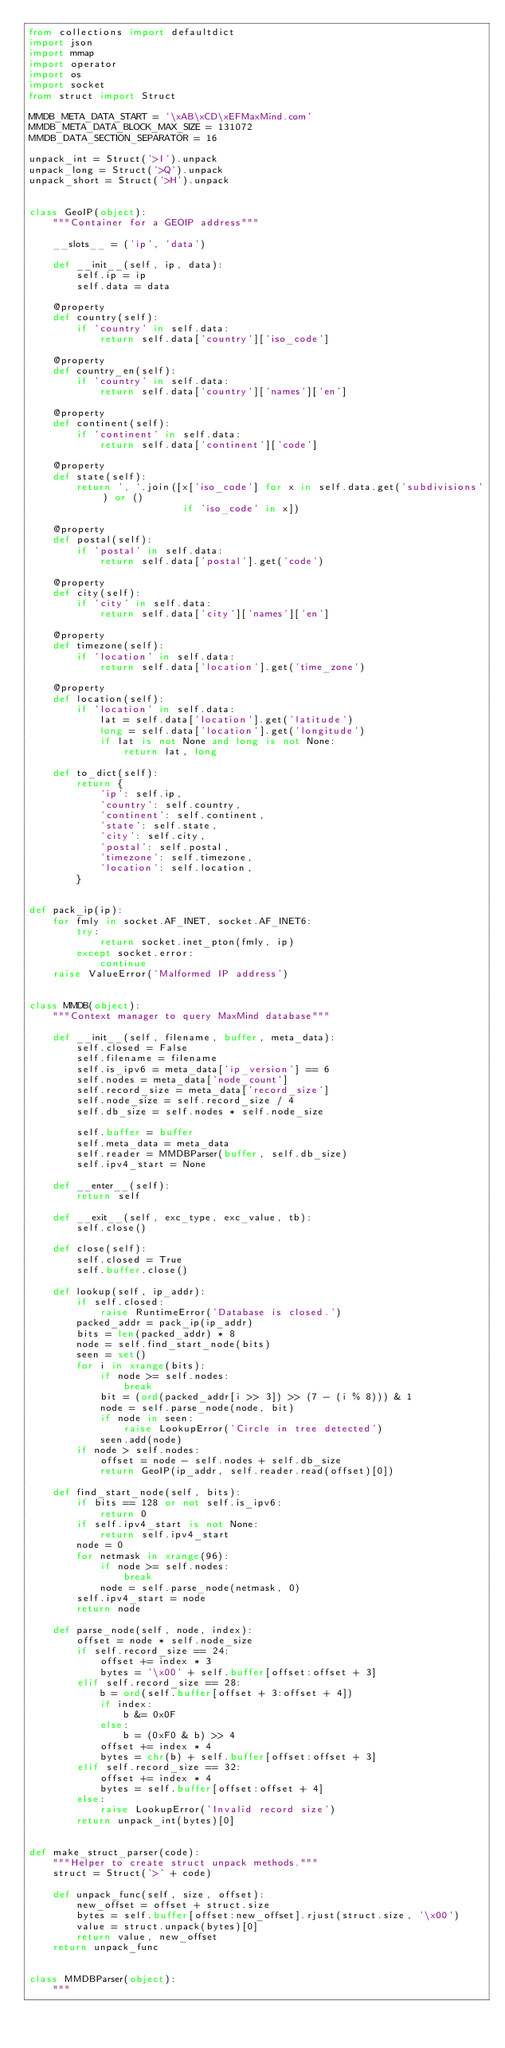Convert code to text. <code><loc_0><loc_0><loc_500><loc_500><_Python_>from collections import defaultdict
import json
import mmap
import operator
import os
import socket
from struct import Struct

MMDB_META_DATA_START = '\xAB\xCD\xEFMaxMind.com'
MMDB_META_DATA_BLOCK_MAX_SIZE = 131072
MMDB_DATA_SECTION_SEPARATOR = 16

unpack_int = Struct('>I').unpack
unpack_long = Struct('>Q').unpack
unpack_short = Struct('>H').unpack


class GeoIP(object):
    """Container for a GEOIP address"""

    __slots__ = ('ip', 'data')

    def __init__(self, ip, data):
        self.ip = ip
        self.data = data

    @property
    def country(self):
        if 'country' in self.data:
            return self.data['country']['iso_code']

    @property
    def country_en(self):
        if 'country' in self.data:
            return self.data['country']['names']['en']

    @property
    def continent(self):
        if 'continent' in self.data:
            return self.data['continent']['code']

    @property
    def state(self):
        return ', '.join([x['iso_code'] for x in self.data.get('subdivisions') or ()
                          if 'iso_code' in x])

    @property
    def postal(self):
        if 'postal' in self.data:
            return self.data['postal'].get('code')

    @property
    def city(self):
        if 'city' in self.data:
            return self.data['city']['names']['en']

    @property
    def timezone(self):
        if 'location' in self.data:
            return self.data['location'].get('time_zone')

    @property
    def location(self):
        if 'location' in self.data:
            lat = self.data['location'].get('latitude')
            long = self.data['location'].get('longitude')
            if lat is not None and long is not None:
                return lat, long

    def to_dict(self):
        return {
            'ip': self.ip,
            'country': self.country,
            'continent': self.continent,
            'state': self.state,
            'city': self.city,
            'postal': self.postal,
            'timezone': self.timezone,
            'location': self.location,
        }


def pack_ip(ip):
    for fmly in socket.AF_INET, socket.AF_INET6:
        try:
            return socket.inet_pton(fmly, ip)
        except socket.error:
            continue
    raise ValueError('Malformed IP address')


class MMDB(object):
    """Context manager to query MaxMind database"""

    def __init__(self, filename, buffer, meta_data):
        self.closed = False
        self.filename = filename
        self.is_ipv6 = meta_data['ip_version'] == 6
        self.nodes = meta_data['node_count']
        self.record_size = meta_data['record_size']
        self.node_size = self.record_size / 4
        self.db_size = self.nodes * self.node_size

        self.buffer = buffer
        self.meta_data = meta_data
        self.reader = MMDBParser(buffer, self.db_size)
        self.ipv4_start = None

    def __enter__(self):
        return self

    def __exit__(self, exc_type, exc_value, tb):
        self.close()

    def close(self):
        self.closed = True
        self.buffer.close()

    def lookup(self, ip_addr):
        if self.closed:
            raise RuntimeError('Database is closed.')
        packed_addr = pack_ip(ip_addr)
        bits = len(packed_addr) * 8
        node = self.find_start_node(bits)
        seen = set()
        for i in xrange(bits):
            if node >= self.nodes:
                break
            bit = (ord(packed_addr[i >> 3]) >> (7 - (i % 8))) & 1
            node = self.parse_node(node, bit)
            if node in seen:
                raise LookupError('Circle in tree detected')
            seen.add(node)
        if node > self.nodes:
            offset = node - self.nodes + self.db_size
            return GeoIP(ip_addr, self.reader.read(offset)[0])

    def find_start_node(self, bits):
        if bits == 128 or not self.is_ipv6:
            return 0
        if self.ipv4_start is not None:
            return self.ipv4_start
        node = 0
        for netmask in xrange(96):
            if node >= self.nodes:
                break
            node = self.parse_node(netmask, 0)
        self.ipv4_start = node
        return node

    def parse_node(self, node, index):
        offset = node * self.node_size
        if self.record_size == 24:
            offset += index * 3
            bytes = '\x00' + self.buffer[offset:offset + 3]
        elif self.record_size == 28:
            b = ord(self.buffer[offset + 3:offset + 4])
            if index:
                b &= 0x0F
            else:
                b = (0xF0 & b) >> 4
            offset += index * 4
            bytes = chr(b) + self.buffer[offset:offset + 3]
        elif self.record_size == 32:
            offset += index * 4
            bytes = self.buffer[offset:offset + 4]
        else:
            raise LookupError('Invalid record size')
        return unpack_int(bytes)[0]


def make_struct_parser(code):
    """Helper to create struct unpack methods."""
    struct = Struct('>' + code)

    def unpack_func(self, size, offset):
        new_offset = offset + struct.size
        bytes = self.buffer[offset:new_offset].rjust(struct.size, '\x00')
        value = struct.unpack(bytes)[0]
        return value, new_offset
    return unpack_func


class MMDBParser(object):
    """</code> 